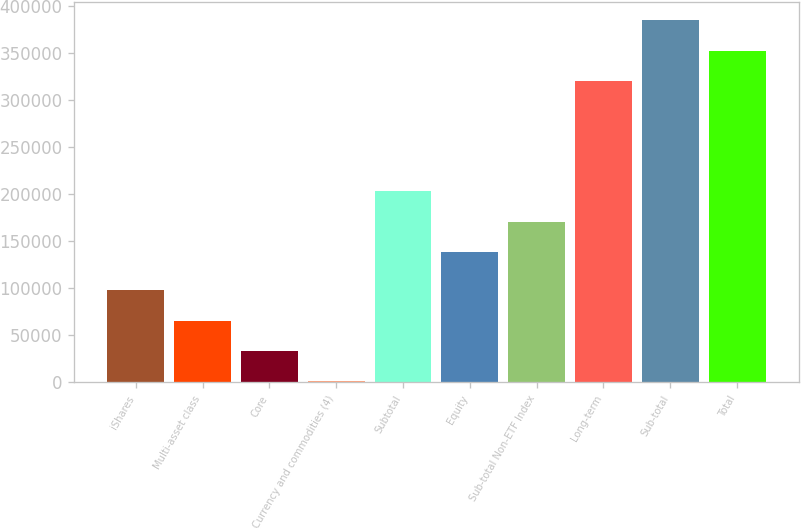Convert chart to OTSL. <chart><loc_0><loc_0><loc_500><loc_500><bar_chart><fcel>iShares<fcel>Multi-asset class<fcel>Core<fcel>Currency and commodities (4)<fcel>Subtotal<fcel>Equity<fcel>Sub-total Non-ETF Index<fcel>Long-term<fcel>Sub-total<fcel>Total<nl><fcel>97569.2<fcel>65481.8<fcel>33394.4<fcel>1307<fcel>202905<fcel>138730<fcel>170817<fcel>320198<fcel>384373<fcel>352285<nl></chart> 